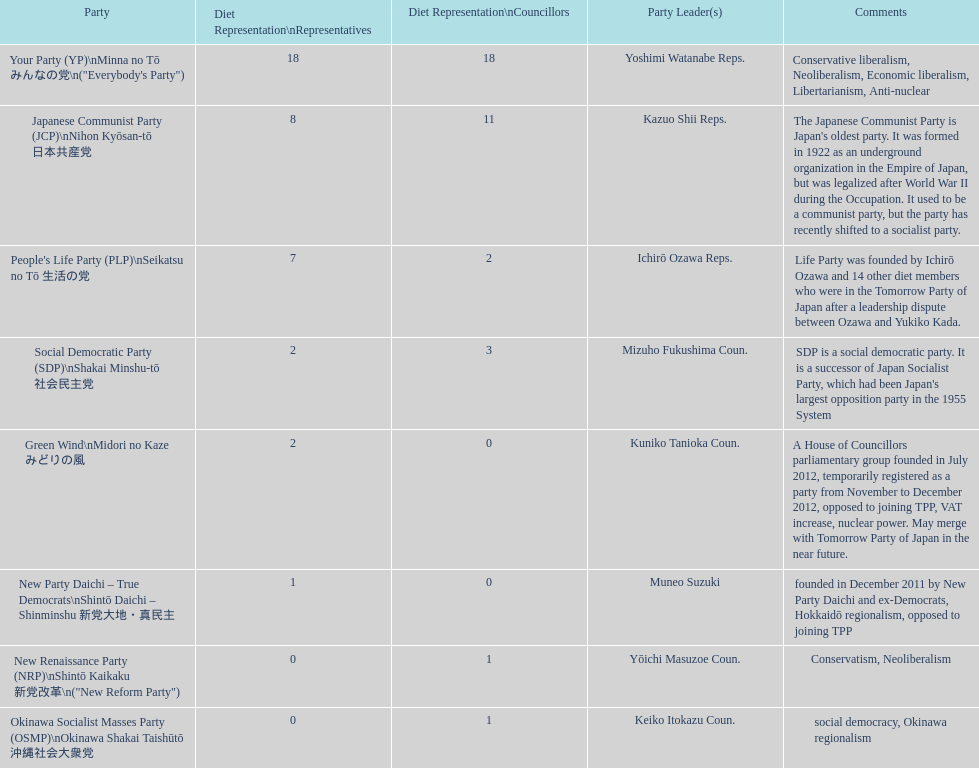Referring to the table, which political party in japan has the longest history? Japanese Communist Party (JCP) Nihon Kyōsan-tō 日本共産党. 